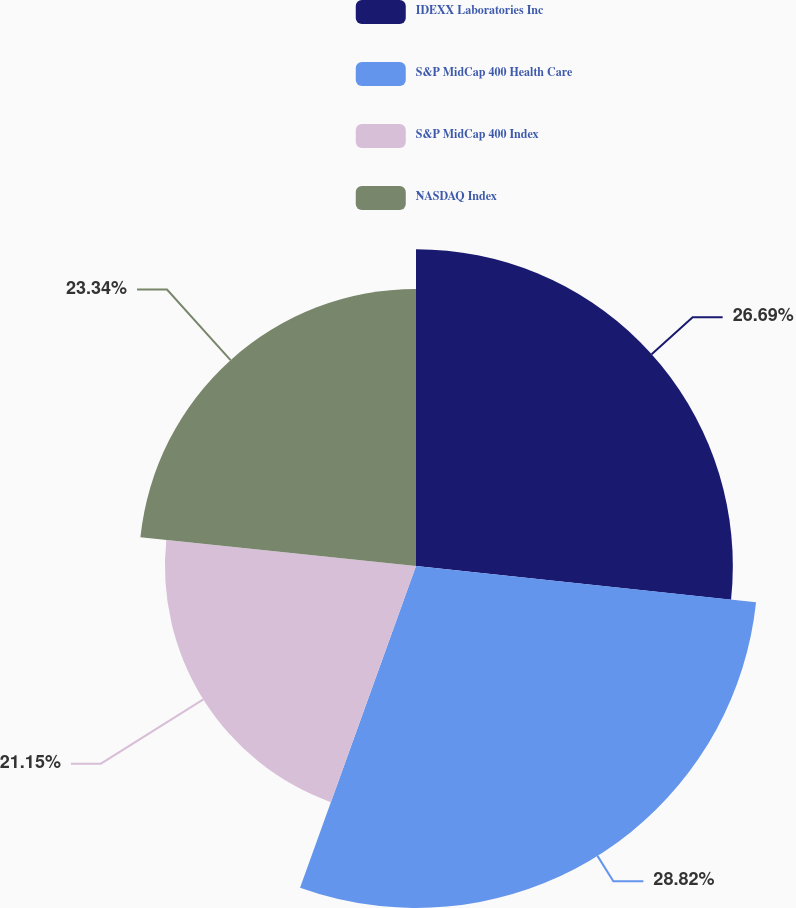<chart> <loc_0><loc_0><loc_500><loc_500><pie_chart><fcel>IDEXX Laboratories Inc<fcel>S&P MidCap 400 Health Care<fcel>S&P MidCap 400 Index<fcel>NASDAQ Index<nl><fcel>26.69%<fcel>28.81%<fcel>21.15%<fcel>23.34%<nl></chart> 